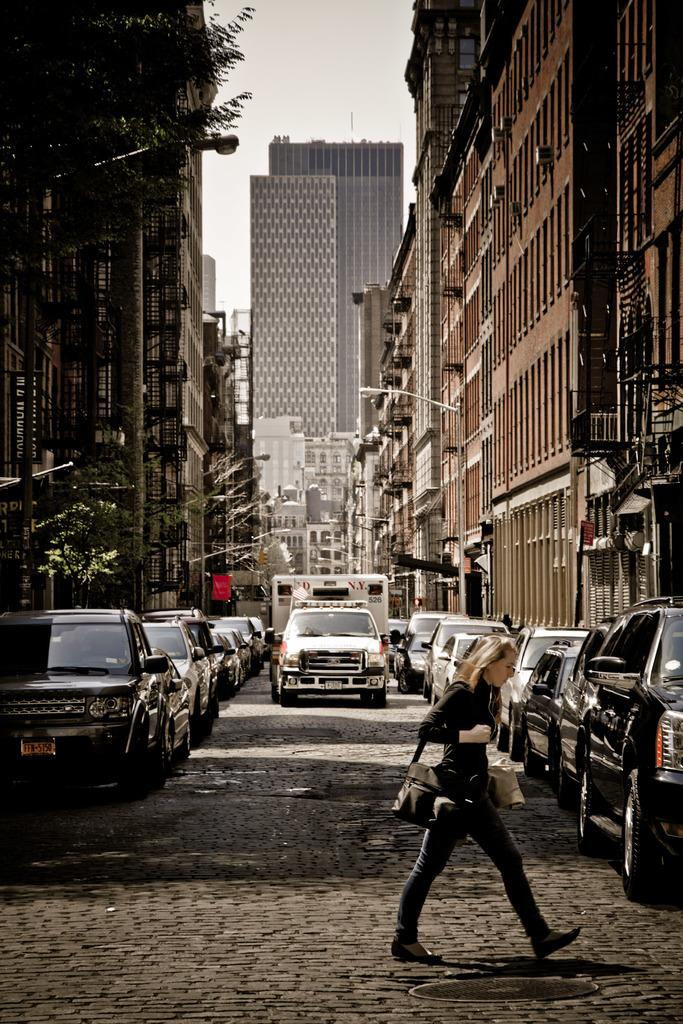Provide a one-sentence caption for the provided image. a woman is crossing a brick street and a FDNY ambulance is driving toward her. 